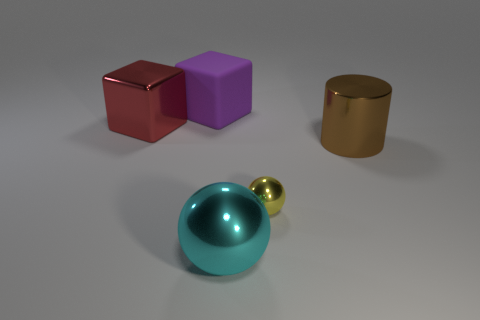Add 2 big purple things. How many objects exist? 7 Subtract all spheres. How many objects are left? 3 Add 2 purple things. How many purple things exist? 3 Subtract 0 yellow cylinders. How many objects are left? 5 Subtract all large blocks. Subtract all small blue matte spheres. How many objects are left? 3 Add 2 metallic cylinders. How many metallic cylinders are left? 3 